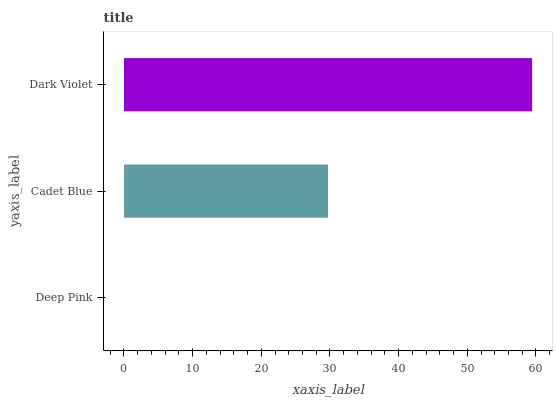Is Deep Pink the minimum?
Answer yes or no. Yes. Is Dark Violet the maximum?
Answer yes or no. Yes. Is Cadet Blue the minimum?
Answer yes or no. No. Is Cadet Blue the maximum?
Answer yes or no. No. Is Cadet Blue greater than Deep Pink?
Answer yes or no. Yes. Is Deep Pink less than Cadet Blue?
Answer yes or no. Yes. Is Deep Pink greater than Cadet Blue?
Answer yes or no. No. Is Cadet Blue less than Deep Pink?
Answer yes or no. No. Is Cadet Blue the high median?
Answer yes or no. Yes. Is Cadet Blue the low median?
Answer yes or no. Yes. Is Dark Violet the high median?
Answer yes or no. No. Is Dark Violet the low median?
Answer yes or no. No. 